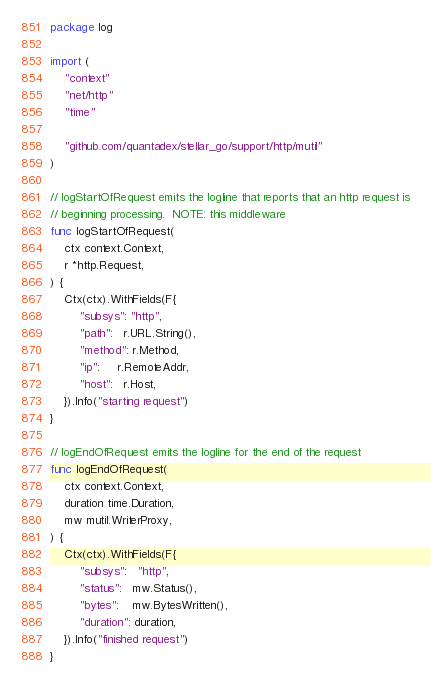Convert code to text. <code><loc_0><loc_0><loc_500><loc_500><_Go_>package log

import (
	"context"
	"net/http"
	"time"

	"github.com/quantadex/stellar_go/support/http/mutil"
)

// logStartOfRequest emits the logline that reports that an http request is
// beginning processing.  NOTE: this middleware
func logStartOfRequest(
	ctx context.Context,
	r *http.Request,
) {
	Ctx(ctx).WithFields(F{
		"subsys": "http",
		"path":   r.URL.String(),
		"method": r.Method,
		"ip":     r.RemoteAddr,
		"host":   r.Host,
	}).Info("starting request")
}

// logEndOfRequest emits the logline for the end of the request
func logEndOfRequest(
	ctx context.Context,
	duration time.Duration,
	mw mutil.WriterProxy,
) {
	Ctx(ctx).WithFields(F{
		"subsys":   "http",
		"status":   mw.Status(),
		"bytes":    mw.BytesWritten(),
		"duration": duration,
	}).Info("finished request")
}
</code> 